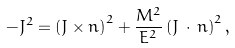<formula> <loc_0><loc_0><loc_500><loc_500>- J ^ { 2 } = \left ( { J } \times { n } \right ) ^ { 2 } + \frac { M ^ { 2 } } { E ^ { 2 } } \left ( { J } \, \cdot \, { n } \right ) ^ { 2 } ,</formula> 